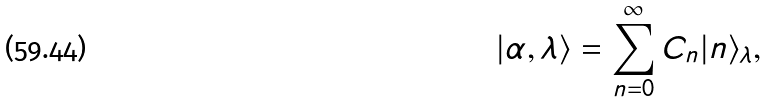<formula> <loc_0><loc_0><loc_500><loc_500>| \alpha , \lambda \rangle = \sum _ { n = 0 } ^ { \infty } C _ { n } | n \rangle _ { \lambda } ,</formula> 